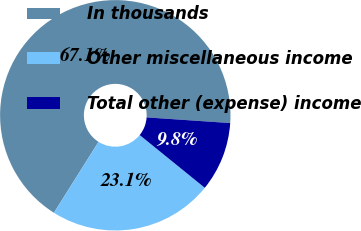Convert chart to OTSL. <chart><loc_0><loc_0><loc_500><loc_500><pie_chart><fcel>In thousands<fcel>Other miscellaneous income<fcel>Total other (expense) income<nl><fcel>67.13%<fcel>23.1%<fcel>9.76%<nl></chart> 